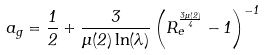Convert formula to latex. <formula><loc_0><loc_0><loc_500><loc_500>a _ { g } = \frac { 1 } { 2 } + \frac { 3 } { \mu ( 2 ) \ln ( \lambda ) } \left ( R _ { e } ^ { \frac { 3 \mu ( 2 ) } { 4 } } - 1 \right ) ^ { - 1 }</formula> 